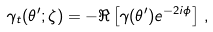Convert formula to latex. <formula><loc_0><loc_0><loc_500><loc_500>\gamma _ { t } ( \theta ^ { \prime } ; \zeta ) = - \Re \left [ \gamma ( \theta ^ { \prime } ) e ^ { - 2 i \phi } \right ] \, ,</formula> 